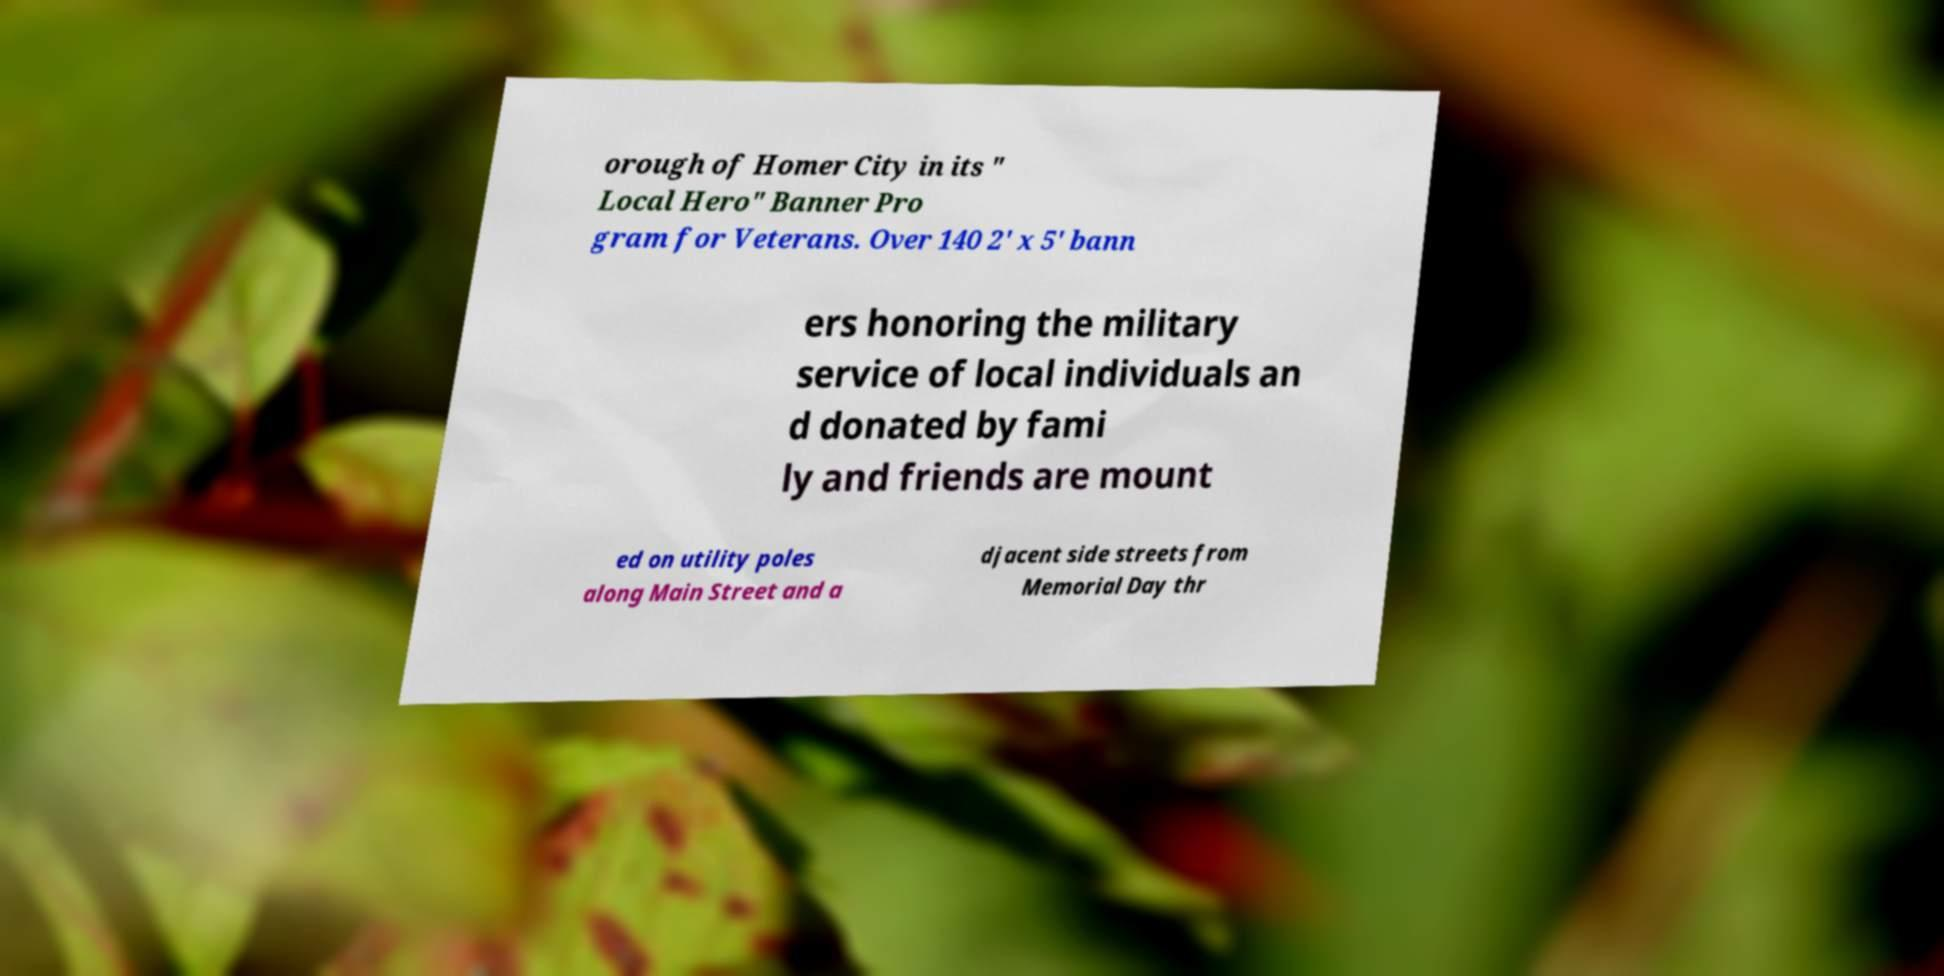Please read and relay the text visible in this image. What does it say? orough of Homer City in its " Local Hero" Banner Pro gram for Veterans. Over 140 2' x 5' bann ers honoring the military service of local individuals an d donated by fami ly and friends are mount ed on utility poles along Main Street and a djacent side streets from Memorial Day thr 